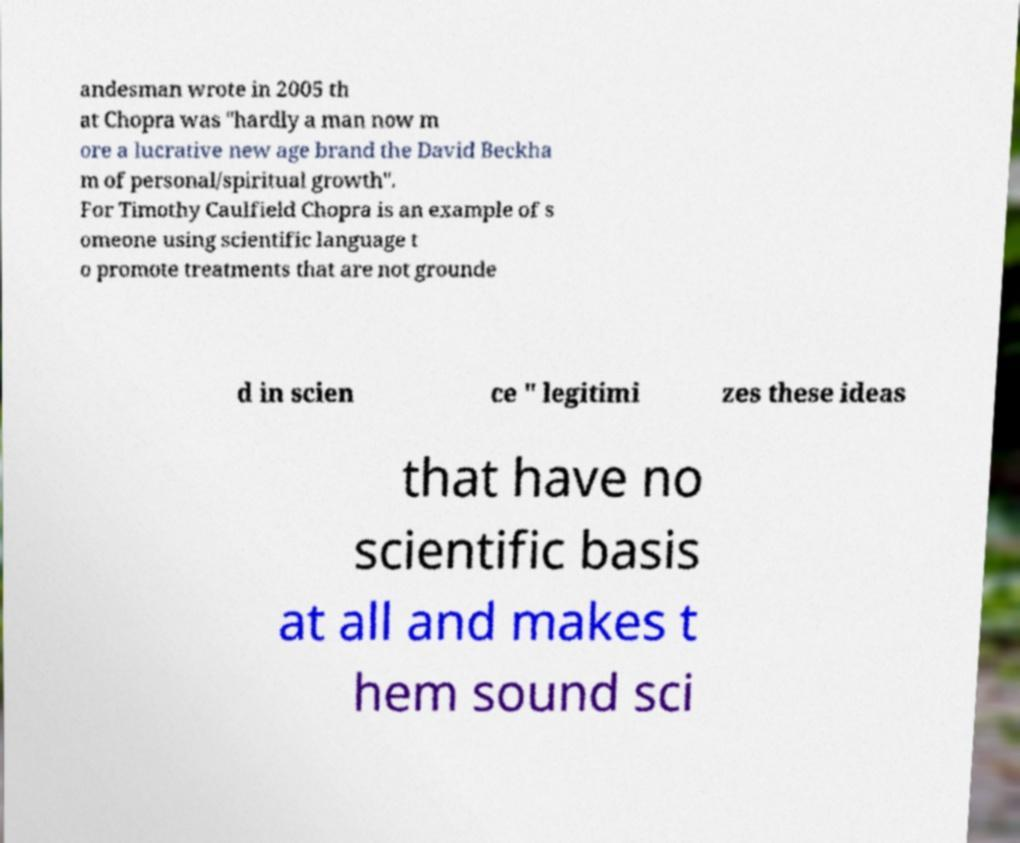For documentation purposes, I need the text within this image transcribed. Could you provide that? andesman wrote in 2005 th at Chopra was "hardly a man now m ore a lucrative new age brand the David Beckha m of personal/spiritual growth". For Timothy Caulfield Chopra is an example of s omeone using scientific language t o promote treatments that are not grounde d in scien ce " legitimi zes these ideas that have no scientific basis at all and makes t hem sound sci 